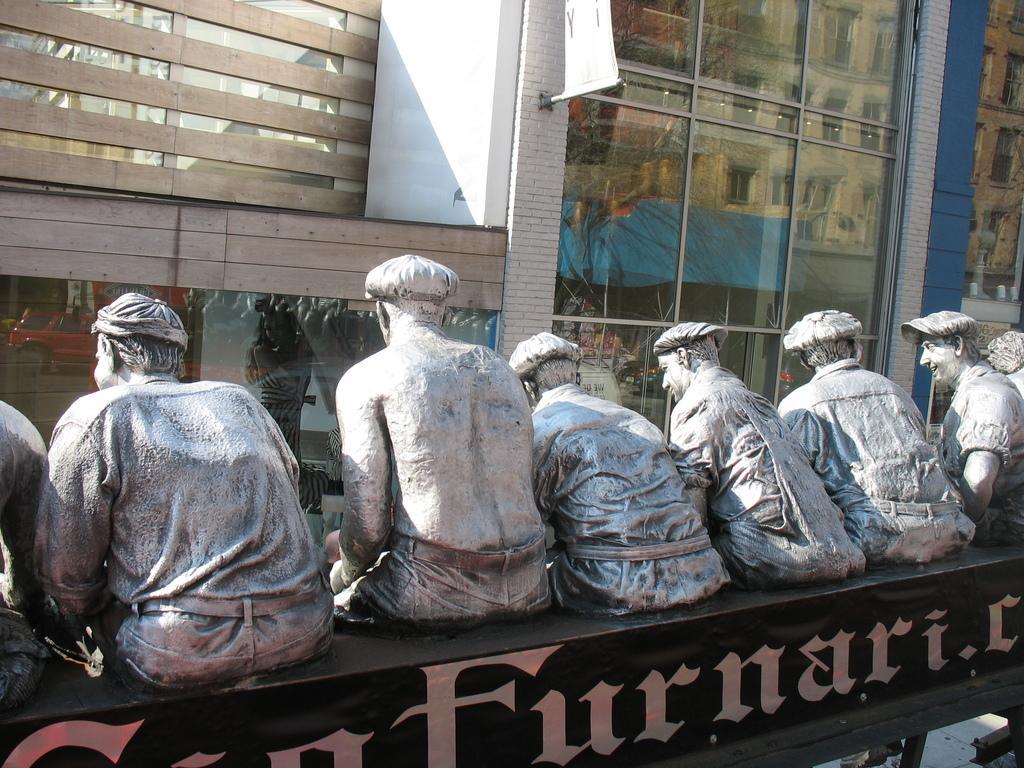Please provide a concise description of this image. In the picture I can see statue of people and something written on a black color object. In the background I can see buildings, framed glass wall and some other objects. 